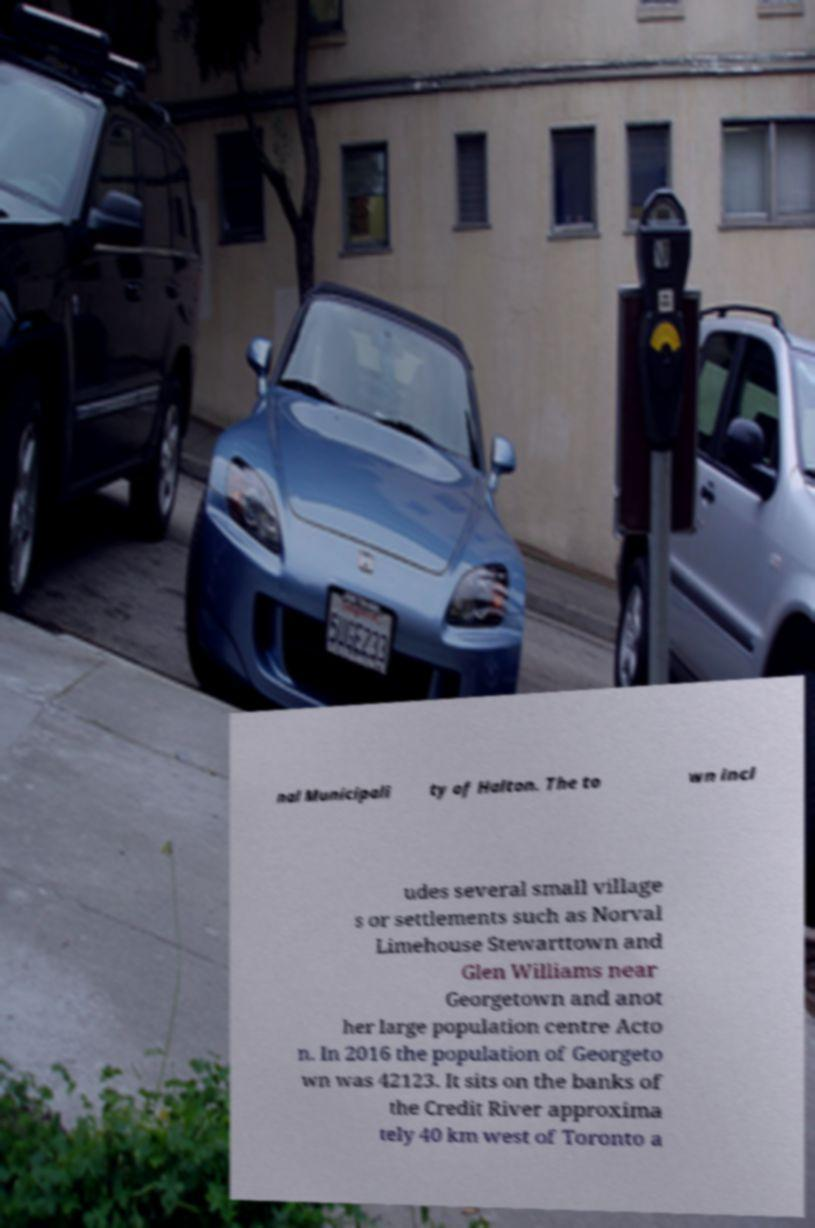Please identify and transcribe the text found in this image. nal Municipali ty of Halton. The to wn incl udes several small village s or settlements such as Norval Limehouse Stewarttown and Glen Williams near Georgetown and anot her large population centre Acto n. In 2016 the population of Georgeto wn was 42123. It sits on the banks of the Credit River approxima tely 40 km west of Toronto a 